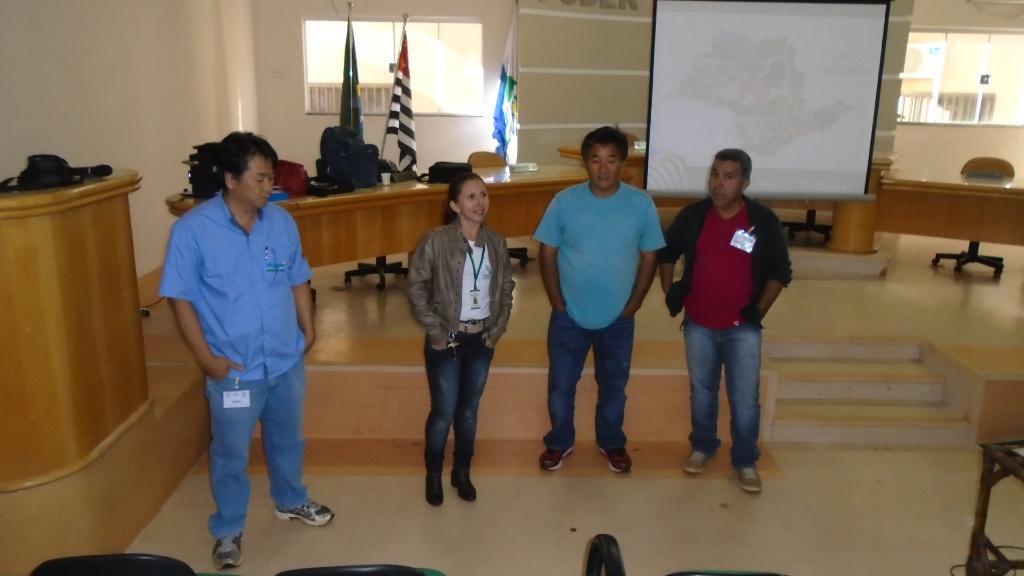Can you describe this image briefly? In this image there are four persons standing on the floor. Behind them there is a table. On the right side there is a screen. On the left side there is a desk on which there is a bag. At the bottom there are chairs. There are three flags around the desk. In the background there are windows. At the bottom there are two steps. 